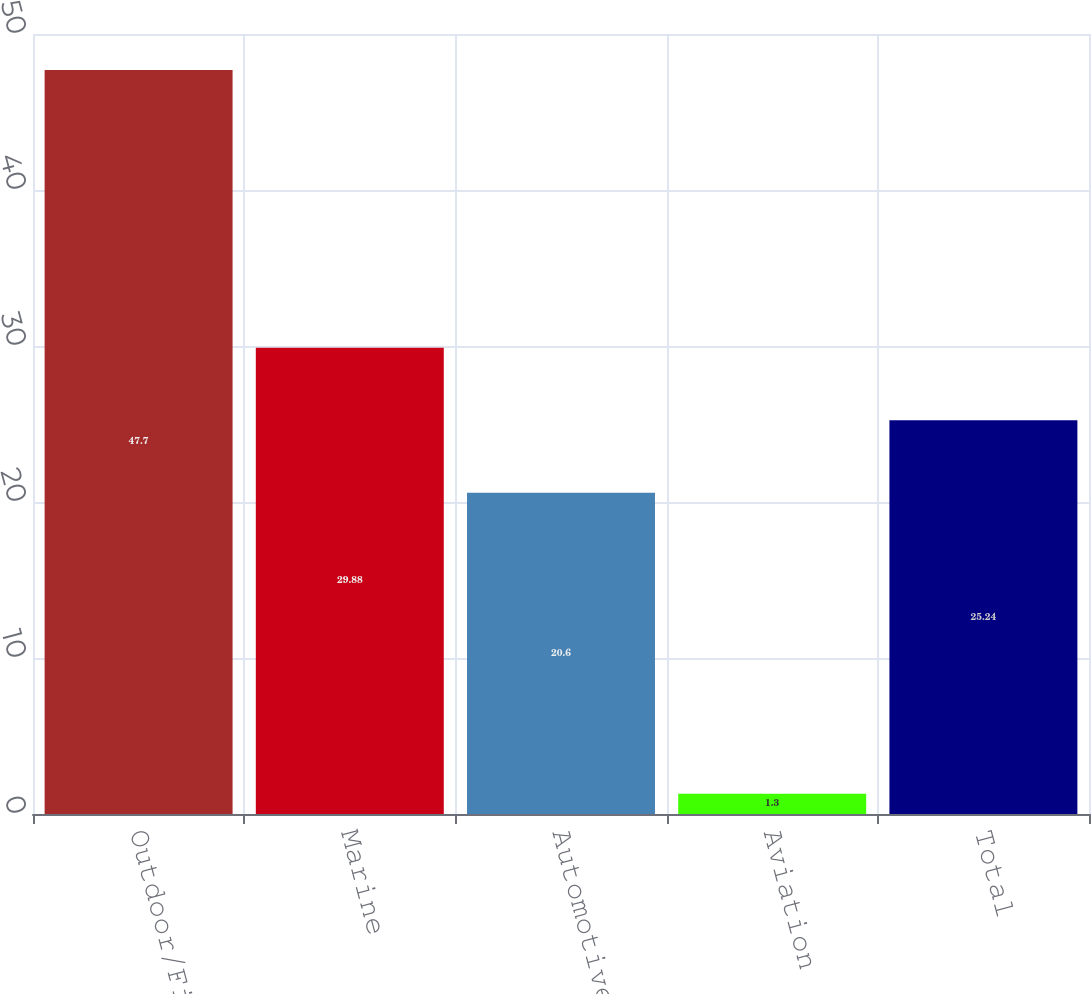Convert chart. <chart><loc_0><loc_0><loc_500><loc_500><bar_chart><fcel>Outdoor/Fitness<fcel>Marine<fcel>Automotive/Mobile<fcel>Aviation<fcel>Total<nl><fcel>47.7<fcel>29.88<fcel>20.6<fcel>1.3<fcel>25.24<nl></chart> 